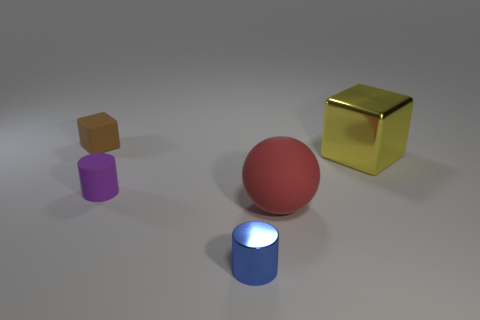How many objects are either metallic things in front of the large metallic object or objects?
Offer a terse response. 5. There is a object that is left of the purple cylinder; what size is it?
Ensure brevity in your answer.  Small. Does the yellow object have the same size as the matte object on the right side of the blue shiny cylinder?
Your response must be concise. Yes. There is a cylinder left of the tiny object on the right side of the matte cylinder; what is its color?
Your answer should be compact. Purple. How many other objects are there of the same color as the matte sphere?
Give a very brief answer. 0. The metallic block is what size?
Your answer should be very brief. Large. Are there more matte balls on the left side of the blue metallic cylinder than purple objects that are behind the brown rubber thing?
Offer a terse response. No. There is a cylinder behind the small metal thing; what number of big matte objects are to the right of it?
Make the answer very short. 1. Does the matte thing behind the big cube have the same shape as the yellow metallic thing?
Give a very brief answer. Yes. There is a big object that is the same shape as the small brown matte thing; what material is it?
Make the answer very short. Metal. 